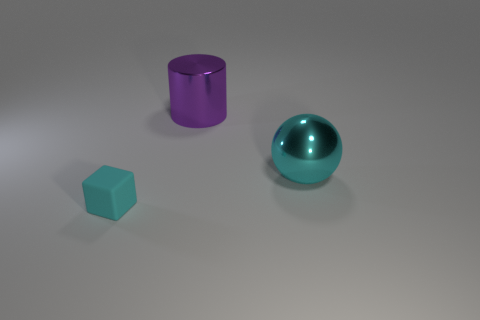How many tiny things are cyan rubber cylinders or cyan metallic balls?
Your answer should be very brief. 0. What size is the metal cylinder?
Your response must be concise. Large. Is there any other thing that has the same material as the large cyan ball?
Ensure brevity in your answer.  Yes. What number of big cyan metallic things are behind the small cyan rubber object?
Make the answer very short. 1. How big is the thing that is in front of the big purple object and left of the cyan shiny thing?
Offer a terse response. Small. Do the metallic ball and the thing to the left of the cylinder have the same color?
Your answer should be compact. Yes. How many purple objects are either large cylinders or small cubes?
Offer a very short reply. 1. The small cyan matte thing has what shape?
Give a very brief answer. Cube. How many other things are there of the same shape as the big cyan shiny thing?
Make the answer very short. 0. What color is the big thing on the left side of the large cyan sphere?
Provide a succinct answer. Purple. 